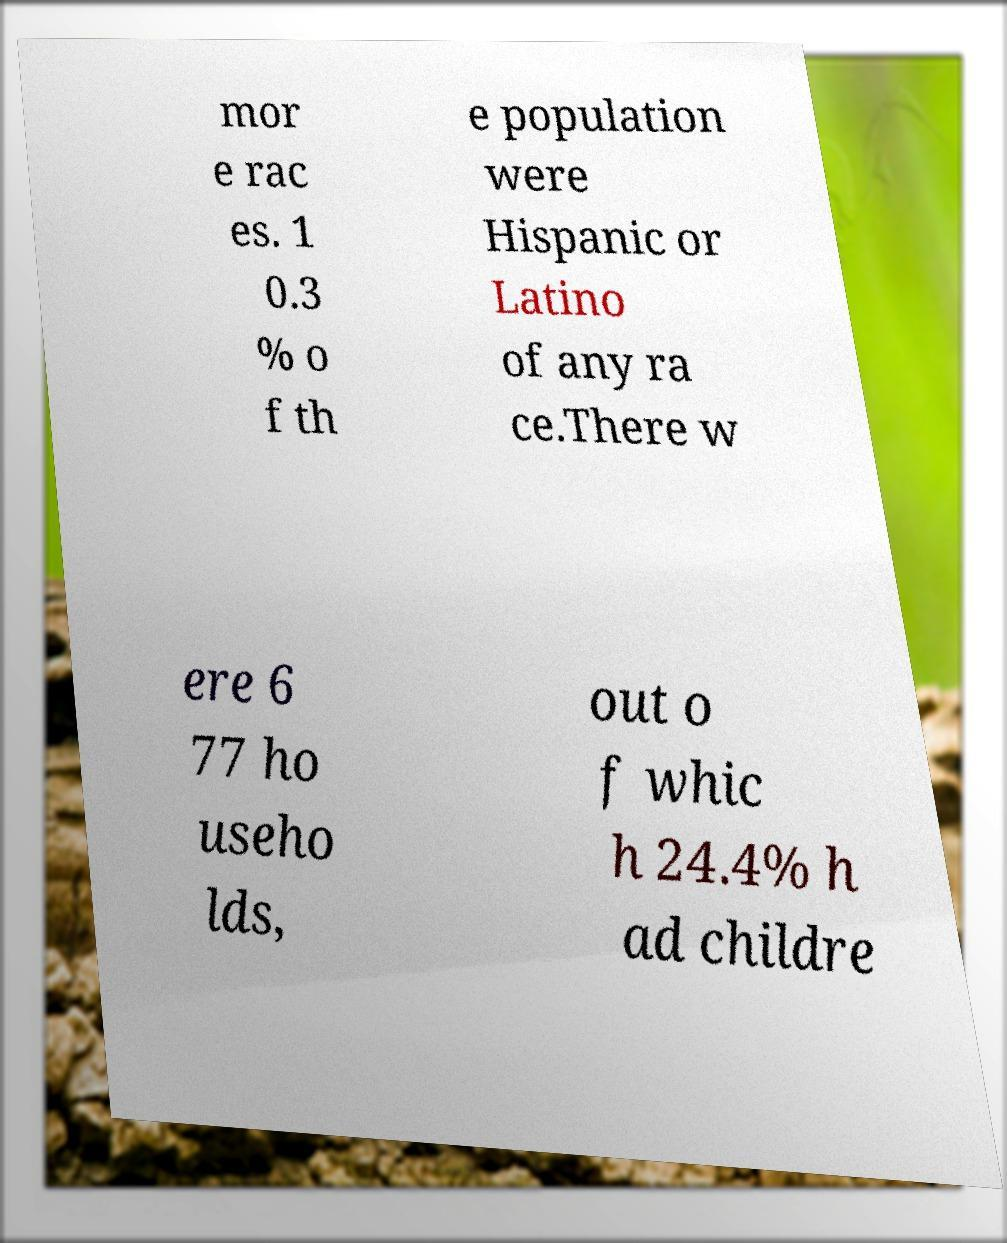Please identify and transcribe the text found in this image. mor e rac es. 1 0.3 % o f th e population were Hispanic or Latino of any ra ce.There w ere 6 77 ho useho lds, out o f whic h 24.4% h ad childre 